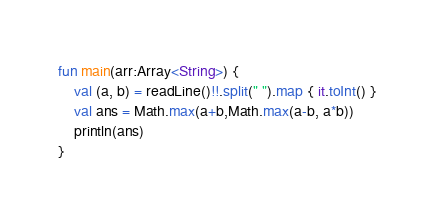Convert code to text. <code><loc_0><loc_0><loc_500><loc_500><_Kotlin_>fun main(arr:Array<String>) {
    val (a, b) = readLine()!!.split(" ").map { it.toInt() }
    val ans = Math.max(a+b,Math.max(a-b, a*b))
    println(ans)
}

</code> 